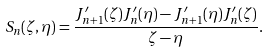Convert formula to latex. <formula><loc_0><loc_0><loc_500><loc_500>S _ { n } ( \zeta , \eta ) = \frac { J _ { n + 1 } ^ { \prime } ( \zeta ) J _ { n } ^ { \prime } ( \eta ) - J _ { n + 1 } ^ { \prime } ( \eta ) J _ { n } ^ { \prime } ( \zeta ) } { \zeta - \eta } .</formula> 